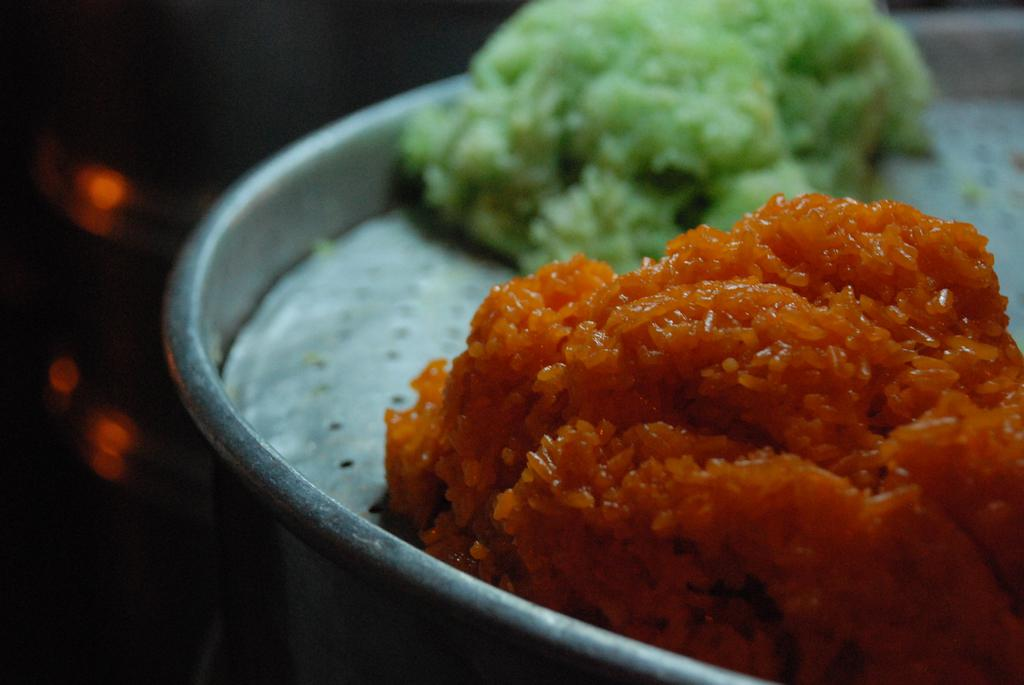What types of items can be seen in the image? There are food items in the image. Can you describe the appearance of the food items? The food items have different colors. Where are the food items located? The food items are in a plate. Can you see the moon in the image? No, the moon is not present in the image. The image only contains food items in a plate. 